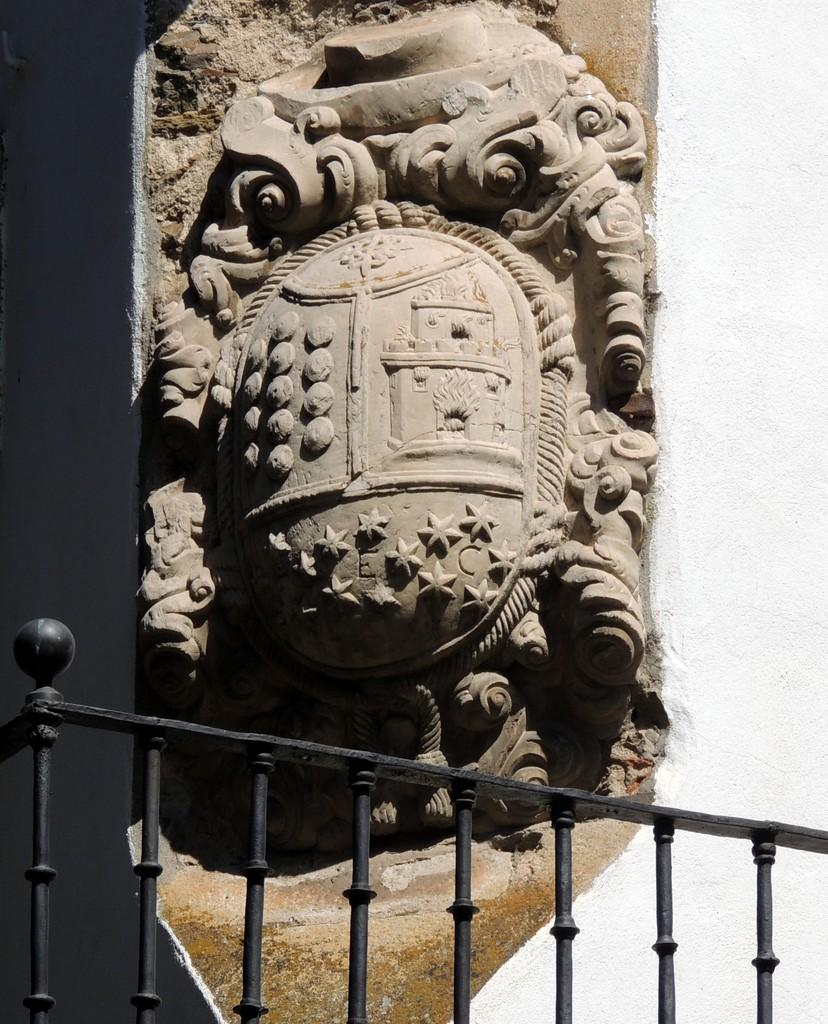What is the main subject of the image? There is a sculpture in the image. What can be seen in the background of the image? There is a fence in the image. Are there any architectural elements present in the image? Yes, there is a pillar in the image. What type of memory is stored in the sculpture in the image? There is no indication in the image that the sculpture stores any memory. 